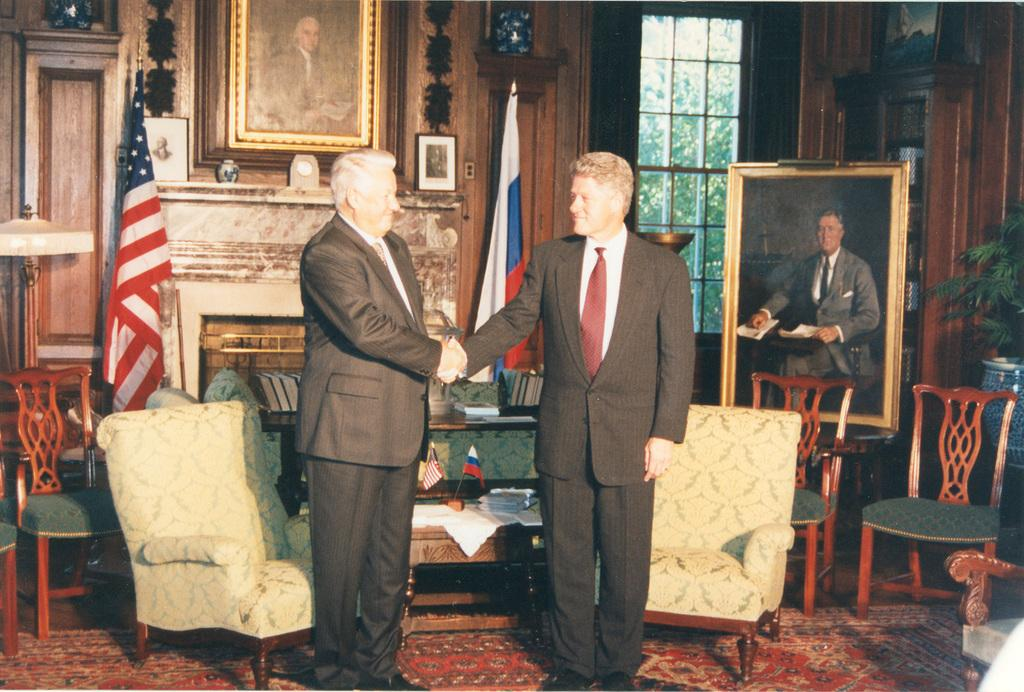What are the two men in the image doing? The men are shaking hands in the image. Where are the men located in the image? The men are on the floor in the image. What can be seen in the background of the image? There is a flag and chairs in the image. What is on the right side of the image? There is a photo or painting on the right side of the image. How many leather jackets are visible in the image? There is no leather jacket present in the image. Is there a playground visible in the image? There is no playground present in the image. 